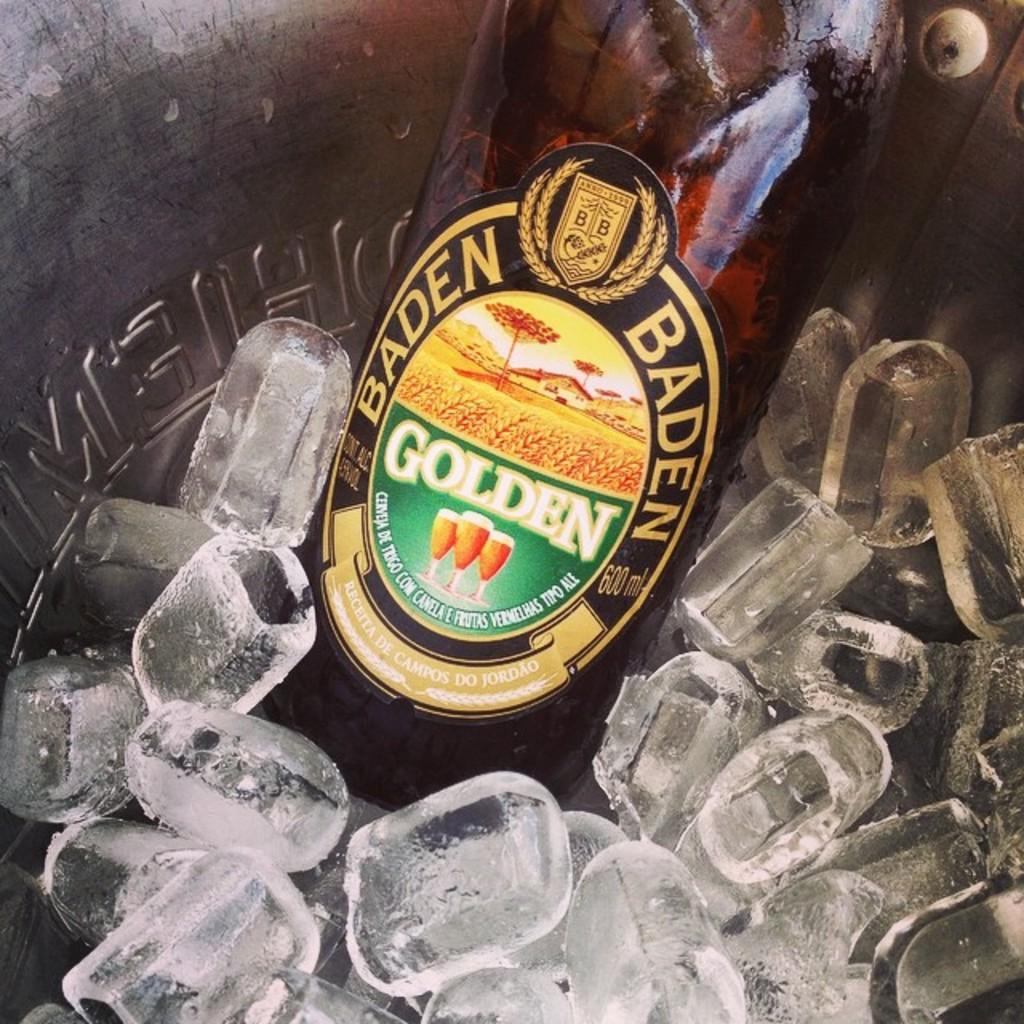What brand of beer is in the ice?
Provide a short and direct response. Baden. How many milliliters are in this bottle?
Ensure brevity in your answer.  600. 